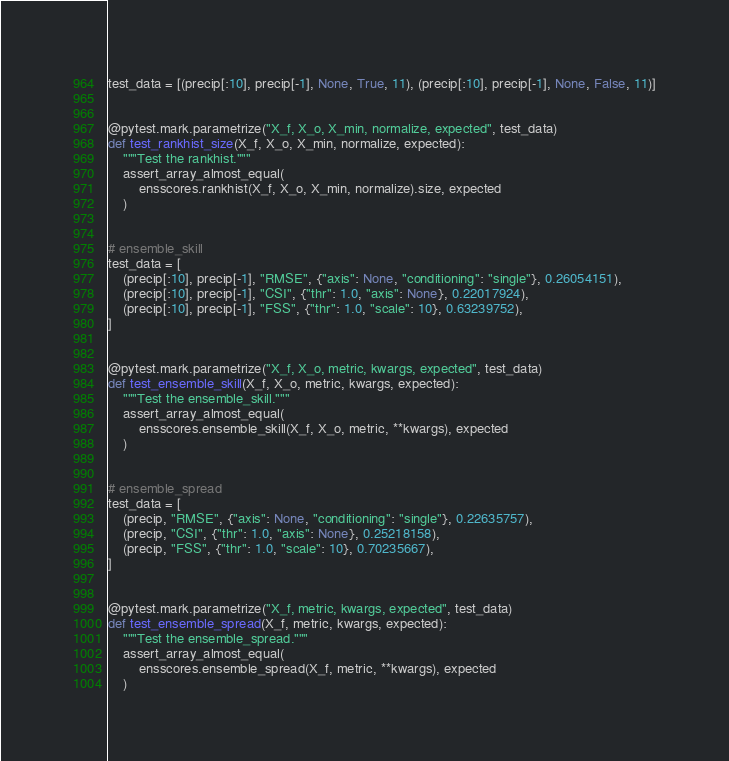Convert code to text. <code><loc_0><loc_0><loc_500><loc_500><_Python_>test_data = [(precip[:10], precip[-1], None, True, 11), (precip[:10], precip[-1], None, False, 11)]


@pytest.mark.parametrize("X_f, X_o, X_min, normalize, expected", test_data)
def test_rankhist_size(X_f, X_o, X_min, normalize, expected):
    """Test the rankhist."""
    assert_array_almost_equal(
        ensscores.rankhist(X_f, X_o, X_min, normalize).size, expected
    )


# ensemble_skill
test_data = [
    (precip[:10], precip[-1], "RMSE", {"axis": None, "conditioning": "single"}, 0.26054151),
    (precip[:10], precip[-1], "CSI", {"thr": 1.0, "axis": None}, 0.22017924),
    (precip[:10], precip[-1], "FSS", {"thr": 1.0, "scale": 10}, 0.63239752),
]


@pytest.mark.parametrize("X_f, X_o, metric, kwargs, expected", test_data)
def test_ensemble_skill(X_f, X_o, metric, kwargs, expected):
    """Test the ensemble_skill."""
    assert_array_almost_equal(
        ensscores.ensemble_skill(X_f, X_o, metric, **kwargs), expected
    )


# ensemble_spread
test_data = [
    (precip, "RMSE", {"axis": None, "conditioning": "single"}, 0.22635757),
    (precip, "CSI", {"thr": 1.0, "axis": None}, 0.25218158),
    (precip, "FSS", {"thr": 1.0, "scale": 10}, 0.70235667),
]


@pytest.mark.parametrize("X_f, metric, kwargs, expected", test_data)
def test_ensemble_spread(X_f, metric, kwargs, expected):
    """Test the ensemble_spread."""
    assert_array_almost_equal(
        ensscores.ensemble_spread(X_f, metric, **kwargs), expected
    )
</code> 